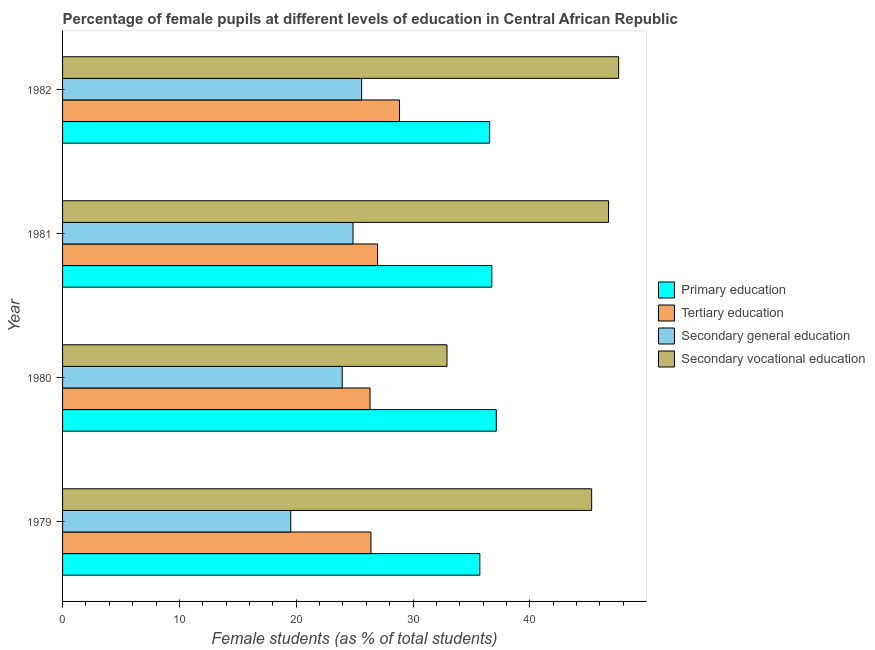How many different coloured bars are there?
Offer a very short reply. 4. Are the number of bars per tick equal to the number of legend labels?
Ensure brevity in your answer.  Yes. Are the number of bars on each tick of the Y-axis equal?
Ensure brevity in your answer.  Yes. How many bars are there on the 1st tick from the bottom?
Give a very brief answer. 4. What is the label of the 3rd group of bars from the top?
Provide a short and direct response. 1980. What is the percentage of female students in tertiary education in 1979?
Make the answer very short. 26.4. Across all years, what is the maximum percentage of female students in secondary education?
Make the answer very short. 25.6. Across all years, what is the minimum percentage of female students in primary education?
Ensure brevity in your answer.  35.72. What is the total percentage of female students in secondary vocational education in the graph?
Offer a terse response. 172.55. What is the difference between the percentage of female students in tertiary education in 1979 and that in 1981?
Provide a short and direct response. -0.57. What is the difference between the percentage of female students in tertiary education in 1980 and the percentage of female students in primary education in 1979?
Your answer should be compact. -9.4. What is the average percentage of female students in primary education per year?
Offer a terse response. 36.54. In the year 1980, what is the difference between the percentage of female students in primary education and percentage of female students in tertiary education?
Your answer should be very brief. 10.8. In how many years, is the percentage of female students in tertiary education greater than 6 %?
Keep it short and to the point. 4. What is the ratio of the percentage of female students in primary education in 1980 to that in 1981?
Your answer should be compact. 1.01. Is the percentage of female students in secondary vocational education in 1980 less than that in 1981?
Give a very brief answer. Yes. Is the difference between the percentage of female students in tertiary education in 1979 and 1982 greater than the difference between the percentage of female students in secondary vocational education in 1979 and 1982?
Offer a terse response. No. What is the difference between the highest and the second highest percentage of female students in secondary education?
Ensure brevity in your answer.  0.74. What is the difference between the highest and the lowest percentage of female students in secondary vocational education?
Your answer should be compact. 14.69. Is the sum of the percentage of female students in secondary vocational education in 1979 and 1982 greater than the maximum percentage of female students in primary education across all years?
Provide a succinct answer. Yes. What does the 4th bar from the top in 1981 represents?
Your response must be concise. Primary education. What does the 3rd bar from the bottom in 1980 represents?
Offer a terse response. Secondary general education. Is it the case that in every year, the sum of the percentage of female students in primary education and percentage of female students in tertiary education is greater than the percentage of female students in secondary education?
Make the answer very short. Yes. Are all the bars in the graph horizontal?
Provide a short and direct response. Yes. How many years are there in the graph?
Your response must be concise. 4. What is the difference between two consecutive major ticks on the X-axis?
Your answer should be very brief. 10. Where does the legend appear in the graph?
Ensure brevity in your answer.  Center right. What is the title of the graph?
Your response must be concise. Percentage of female pupils at different levels of education in Central African Republic. Does "Business regulatory environment" appear as one of the legend labels in the graph?
Ensure brevity in your answer.  No. What is the label or title of the X-axis?
Your response must be concise. Female students (as % of total students). What is the Female students (as % of total students) of Primary education in 1979?
Keep it short and to the point. 35.72. What is the Female students (as % of total students) in Tertiary education in 1979?
Your answer should be compact. 26.4. What is the Female students (as % of total students) of Secondary general education in 1979?
Provide a short and direct response. 19.54. What is the Female students (as % of total students) of Secondary vocational education in 1979?
Make the answer very short. 45.29. What is the Female students (as % of total students) of Primary education in 1980?
Your answer should be very brief. 37.13. What is the Female students (as % of total students) of Tertiary education in 1980?
Keep it short and to the point. 26.32. What is the Female students (as % of total students) in Secondary general education in 1980?
Your response must be concise. 23.94. What is the Female students (as % of total students) of Secondary vocational education in 1980?
Provide a succinct answer. 32.91. What is the Female students (as % of total students) in Primary education in 1981?
Your answer should be very brief. 36.75. What is the Female students (as % of total students) in Tertiary education in 1981?
Offer a very short reply. 26.97. What is the Female students (as % of total students) in Secondary general education in 1981?
Offer a very short reply. 24.86. What is the Female students (as % of total students) in Secondary vocational education in 1981?
Give a very brief answer. 46.74. What is the Female students (as % of total students) of Primary education in 1982?
Provide a succinct answer. 36.56. What is the Female students (as % of total students) in Tertiary education in 1982?
Your answer should be very brief. 28.84. What is the Female students (as % of total students) of Secondary general education in 1982?
Offer a terse response. 25.6. What is the Female students (as % of total students) in Secondary vocational education in 1982?
Ensure brevity in your answer.  47.6. Across all years, what is the maximum Female students (as % of total students) in Primary education?
Your response must be concise. 37.13. Across all years, what is the maximum Female students (as % of total students) in Tertiary education?
Make the answer very short. 28.84. Across all years, what is the maximum Female students (as % of total students) of Secondary general education?
Your response must be concise. 25.6. Across all years, what is the maximum Female students (as % of total students) of Secondary vocational education?
Ensure brevity in your answer.  47.6. Across all years, what is the minimum Female students (as % of total students) of Primary education?
Make the answer very short. 35.72. Across all years, what is the minimum Female students (as % of total students) in Tertiary education?
Provide a succinct answer. 26.32. Across all years, what is the minimum Female students (as % of total students) of Secondary general education?
Your answer should be compact. 19.54. Across all years, what is the minimum Female students (as % of total students) in Secondary vocational education?
Your answer should be very brief. 32.91. What is the total Female students (as % of total students) of Primary education in the graph?
Your response must be concise. 146.16. What is the total Female students (as % of total students) of Tertiary education in the graph?
Your answer should be very brief. 108.53. What is the total Female students (as % of total students) of Secondary general education in the graph?
Keep it short and to the point. 93.94. What is the total Female students (as % of total students) of Secondary vocational education in the graph?
Provide a short and direct response. 172.55. What is the difference between the Female students (as % of total students) in Primary education in 1979 and that in 1980?
Provide a short and direct response. -1.41. What is the difference between the Female students (as % of total students) of Tertiary education in 1979 and that in 1980?
Offer a very short reply. 0.08. What is the difference between the Female students (as % of total students) of Secondary general education in 1979 and that in 1980?
Keep it short and to the point. -4.41. What is the difference between the Female students (as % of total students) in Secondary vocational education in 1979 and that in 1980?
Your answer should be compact. 12.38. What is the difference between the Female students (as % of total students) of Primary education in 1979 and that in 1981?
Ensure brevity in your answer.  -1.03. What is the difference between the Female students (as % of total students) in Tertiary education in 1979 and that in 1981?
Your response must be concise. -0.57. What is the difference between the Female students (as % of total students) in Secondary general education in 1979 and that in 1981?
Your answer should be very brief. -5.33. What is the difference between the Female students (as % of total students) of Secondary vocational education in 1979 and that in 1981?
Provide a succinct answer. -1.45. What is the difference between the Female students (as % of total students) of Primary education in 1979 and that in 1982?
Keep it short and to the point. -0.84. What is the difference between the Female students (as % of total students) of Tertiary education in 1979 and that in 1982?
Offer a terse response. -2.44. What is the difference between the Female students (as % of total students) in Secondary general education in 1979 and that in 1982?
Provide a succinct answer. -6.07. What is the difference between the Female students (as % of total students) in Secondary vocational education in 1979 and that in 1982?
Ensure brevity in your answer.  -2.31. What is the difference between the Female students (as % of total students) in Primary education in 1980 and that in 1981?
Ensure brevity in your answer.  0.38. What is the difference between the Female students (as % of total students) of Tertiary education in 1980 and that in 1981?
Make the answer very short. -0.64. What is the difference between the Female students (as % of total students) of Secondary general education in 1980 and that in 1981?
Make the answer very short. -0.92. What is the difference between the Female students (as % of total students) of Secondary vocational education in 1980 and that in 1981?
Your answer should be very brief. -13.83. What is the difference between the Female students (as % of total students) in Primary education in 1980 and that in 1982?
Make the answer very short. 0.57. What is the difference between the Female students (as % of total students) in Tertiary education in 1980 and that in 1982?
Ensure brevity in your answer.  -2.52. What is the difference between the Female students (as % of total students) of Secondary general education in 1980 and that in 1982?
Offer a very short reply. -1.66. What is the difference between the Female students (as % of total students) in Secondary vocational education in 1980 and that in 1982?
Your answer should be very brief. -14.69. What is the difference between the Female students (as % of total students) of Primary education in 1981 and that in 1982?
Provide a short and direct response. 0.19. What is the difference between the Female students (as % of total students) in Tertiary education in 1981 and that in 1982?
Offer a terse response. -1.87. What is the difference between the Female students (as % of total students) of Secondary general education in 1981 and that in 1982?
Your response must be concise. -0.74. What is the difference between the Female students (as % of total students) in Secondary vocational education in 1981 and that in 1982?
Your answer should be compact. -0.86. What is the difference between the Female students (as % of total students) of Primary education in 1979 and the Female students (as % of total students) of Tertiary education in 1980?
Ensure brevity in your answer.  9.4. What is the difference between the Female students (as % of total students) of Primary education in 1979 and the Female students (as % of total students) of Secondary general education in 1980?
Ensure brevity in your answer.  11.78. What is the difference between the Female students (as % of total students) in Primary education in 1979 and the Female students (as % of total students) in Secondary vocational education in 1980?
Your answer should be very brief. 2.81. What is the difference between the Female students (as % of total students) of Tertiary education in 1979 and the Female students (as % of total students) of Secondary general education in 1980?
Your answer should be very brief. 2.46. What is the difference between the Female students (as % of total students) of Tertiary education in 1979 and the Female students (as % of total students) of Secondary vocational education in 1980?
Give a very brief answer. -6.51. What is the difference between the Female students (as % of total students) in Secondary general education in 1979 and the Female students (as % of total students) in Secondary vocational education in 1980?
Your answer should be compact. -13.38. What is the difference between the Female students (as % of total students) in Primary education in 1979 and the Female students (as % of total students) in Tertiary education in 1981?
Ensure brevity in your answer.  8.75. What is the difference between the Female students (as % of total students) of Primary education in 1979 and the Female students (as % of total students) of Secondary general education in 1981?
Ensure brevity in your answer.  10.86. What is the difference between the Female students (as % of total students) of Primary education in 1979 and the Female students (as % of total students) of Secondary vocational education in 1981?
Offer a very short reply. -11.02. What is the difference between the Female students (as % of total students) in Tertiary education in 1979 and the Female students (as % of total students) in Secondary general education in 1981?
Give a very brief answer. 1.54. What is the difference between the Female students (as % of total students) of Tertiary education in 1979 and the Female students (as % of total students) of Secondary vocational education in 1981?
Your answer should be compact. -20.34. What is the difference between the Female students (as % of total students) in Secondary general education in 1979 and the Female students (as % of total students) in Secondary vocational education in 1981?
Give a very brief answer. -27.21. What is the difference between the Female students (as % of total students) in Primary education in 1979 and the Female students (as % of total students) in Tertiary education in 1982?
Ensure brevity in your answer.  6.88. What is the difference between the Female students (as % of total students) in Primary education in 1979 and the Female students (as % of total students) in Secondary general education in 1982?
Offer a terse response. 10.12. What is the difference between the Female students (as % of total students) of Primary education in 1979 and the Female students (as % of total students) of Secondary vocational education in 1982?
Your answer should be compact. -11.88. What is the difference between the Female students (as % of total students) of Tertiary education in 1979 and the Female students (as % of total students) of Secondary general education in 1982?
Your answer should be very brief. 0.8. What is the difference between the Female students (as % of total students) of Tertiary education in 1979 and the Female students (as % of total students) of Secondary vocational education in 1982?
Your answer should be very brief. -21.2. What is the difference between the Female students (as % of total students) in Secondary general education in 1979 and the Female students (as % of total students) in Secondary vocational education in 1982?
Your response must be concise. -28.07. What is the difference between the Female students (as % of total students) in Primary education in 1980 and the Female students (as % of total students) in Tertiary education in 1981?
Provide a succinct answer. 10.16. What is the difference between the Female students (as % of total students) in Primary education in 1980 and the Female students (as % of total students) in Secondary general education in 1981?
Provide a succinct answer. 12.26. What is the difference between the Female students (as % of total students) in Primary education in 1980 and the Female students (as % of total students) in Secondary vocational education in 1981?
Your answer should be compact. -9.61. What is the difference between the Female students (as % of total students) in Tertiary education in 1980 and the Female students (as % of total students) in Secondary general education in 1981?
Ensure brevity in your answer.  1.46. What is the difference between the Female students (as % of total students) in Tertiary education in 1980 and the Female students (as % of total students) in Secondary vocational education in 1981?
Offer a very short reply. -20.42. What is the difference between the Female students (as % of total students) of Secondary general education in 1980 and the Female students (as % of total students) of Secondary vocational education in 1981?
Keep it short and to the point. -22.8. What is the difference between the Female students (as % of total students) in Primary education in 1980 and the Female students (as % of total students) in Tertiary education in 1982?
Offer a terse response. 8.29. What is the difference between the Female students (as % of total students) of Primary education in 1980 and the Female students (as % of total students) of Secondary general education in 1982?
Your answer should be compact. 11.53. What is the difference between the Female students (as % of total students) in Primary education in 1980 and the Female students (as % of total students) in Secondary vocational education in 1982?
Give a very brief answer. -10.48. What is the difference between the Female students (as % of total students) in Tertiary education in 1980 and the Female students (as % of total students) in Secondary general education in 1982?
Ensure brevity in your answer.  0.72. What is the difference between the Female students (as % of total students) in Tertiary education in 1980 and the Female students (as % of total students) in Secondary vocational education in 1982?
Offer a very short reply. -21.28. What is the difference between the Female students (as % of total students) in Secondary general education in 1980 and the Female students (as % of total students) in Secondary vocational education in 1982?
Provide a short and direct response. -23.66. What is the difference between the Female students (as % of total students) of Primary education in 1981 and the Female students (as % of total students) of Tertiary education in 1982?
Provide a short and direct response. 7.91. What is the difference between the Female students (as % of total students) in Primary education in 1981 and the Female students (as % of total students) in Secondary general education in 1982?
Give a very brief answer. 11.15. What is the difference between the Female students (as % of total students) of Primary education in 1981 and the Female students (as % of total students) of Secondary vocational education in 1982?
Make the answer very short. -10.86. What is the difference between the Female students (as % of total students) of Tertiary education in 1981 and the Female students (as % of total students) of Secondary general education in 1982?
Offer a terse response. 1.37. What is the difference between the Female students (as % of total students) in Tertiary education in 1981 and the Female students (as % of total students) in Secondary vocational education in 1982?
Give a very brief answer. -20.64. What is the difference between the Female students (as % of total students) of Secondary general education in 1981 and the Female students (as % of total students) of Secondary vocational education in 1982?
Provide a succinct answer. -22.74. What is the average Female students (as % of total students) of Primary education per year?
Provide a succinct answer. 36.54. What is the average Female students (as % of total students) of Tertiary education per year?
Offer a terse response. 27.13. What is the average Female students (as % of total students) in Secondary general education per year?
Make the answer very short. 23.49. What is the average Female students (as % of total students) in Secondary vocational education per year?
Provide a short and direct response. 43.14. In the year 1979, what is the difference between the Female students (as % of total students) in Primary education and Female students (as % of total students) in Tertiary education?
Your response must be concise. 9.32. In the year 1979, what is the difference between the Female students (as % of total students) of Primary education and Female students (as % of total students) of Secondary general education?
Your answer should be compact. 16.19. In the year 1979, what is the difference between the Female students (as % of total students) of Primary education and Female students (as % of total students) of Secondary vocational education?
Your answer should be compact. -9.57. In the year 1979, what is the difference between the Female students (as % of total students) of Tertiary education and Female students (as % of total students) of Secondary general education?
Give a very brief answer. 6.87. In the year 1979, what is the difference between the Female students (as % of total students) in Tertiary education and Female students (as % of total students) in Secondary vocational education?
Your answer should be very brief. -18.89. In the year 1979, what is the difference between the Female students (as % of total students) in Secondary general education and Female students (as % of total students) in Secondary vocational education?
Your answer should be very brief. -25.76. In the year 1980, what is the difference between the Female students (as % of total students) of Primary education and Female students (as % of total students) of Tertiary education?
Keep it short and to the point. 10.81. In the year 1980, what is the difference between the Female students (as % of total students) in Primary education and Female students (as % of total students) in Secondary general education?
Your response must be concise. 13.19. In the year 1980, what is the difference between the Female students (as % of total students) in Primary education and Female students (as % of total students) in Secondary vocational education?
Your response must be concise. 4.22. In the year 1980, what is the difference between the Female students (as % of total students) of Tertiary education and Female students (as % of total students) of Secondary general education?
Offer a terse response. 2.38. In the year 1980, what is the difference between the Female students (as % of total students) in Tertiary education and Female students (as % of total students) in Secondary vocational education?
Offer a very short reply. -6.59. In the year 1980, what is the difference between the Female students (as % of total students) in Secondary general education and Female students (as % of total students) in Secondary vocational education?
Your response must be concise. -8.97. In the year 1981, what is the difference between the Female students (as % of total students) in Primary education and Female students (as % of total students) in Tertiary education?
Provide a succinct answer. 9.78. In the year 1981, what is the difference between the Female students (as % of total students) in Primary education and Female students (as % of total students) in Secondary general education?
Your answer should be very brief. 11.89. In the year 1981, what is the difference between the Female students (as % of total students) of Primary education and Female students (as % of total students) of Secondary vocational education?
Keep it short and to the point. -9.99. In the year 1981, what is the difference between the Female students (as % of total students) in Tertiary education and Female students (as % of total students) in Secondary general education?
Offer a terse response. 2.1. In the year 1981, what is the difference between the Female students (as % of total students) of Tertiary education and Female students (as % of total students) of Secondary vocational education?
Ensure brevity in your answer.  -19.77. In the year 1981, what is the difference between the Female students (as % of total students) of Secondary general education and Female students (as % of total students) of Secondary vocational education?
Your response must be concise. -21.88. In the year 1982, what is the difference between the Female students (as % of total students) in Primary education and Female students (as % of total students) in Tertiary education?
Provide a short and direct response. 7.72. In the year 1982, what is the difference between the Female students (as % of total students) of Primary education and Female students (as % of total students) of Secondary general education?
Your response must be concise. 10.96. In the year 1982, what is the difference between the Female students (as % of total students) of Primary education and Female students (as % of total students) of Secondary vocational education?
Your answer should be very brief. -11.04. In the year 1982, what is the difference between the Female students (as % of total students) in Tertiary education and Female students (as % of total students) in Secondary general education?
Your response must be concise. 3.24. In the year 1982, what is the difference between the Female students (as % of total students) in Tertiary education and Female students (as % of total students) in Secondary vocational education?
Your answer should be compact. -18.76. In the year 1982, what is the difference between the Female students (as % of total students) in Secondary general education and Female students (as % of total students) in Secondary vocational education?
Provide a short and direct response. -22. What is the ratio of the Female students (as % of total students) in Primary education in 1979 to that in 1980?
Keep it short and to the point. 0.96. What is the ratio of the Female students (as % of total students) of Secondary general education in 1979 to that in 1980?
Make the answer very short. 0.82. What is the ratio of the Female students (as % of total students) of Secondary vocational education in 1979 to that in 1980?
Make the answer very short. 1.38. What is the ratio of the Female students (as % of total students) in Primary education in 1979 to that in 1981?
Your response must be concise. 0.97. What is the ratio of the Female students (as % of total students) of Tertiary education in 1979 to that in 1981?
Your response must be concise. 0.98. What is the ratio of the Female students (as % of total students) of Secondary general education in 1979 to that in 1981?
Offer a very short reply. 0.79. What is the ratio of the Female students (as % of total students) in Secondary vocational education in 1979 to that in 1981?
Your answer should be very brief. 0.97. What is the ratio of the Female students (as % of total students) in Tertiary education in 1979 to that in 1982?
Offer a terse response. 0.92. What is the ratio of the Female students (as % of total students) in Secondary general education in 1979 to that in 1982?
Your answer should be very brief. 0.76. What is the ratio of the Female students (as % of total students) of Secondary vocational education in 1979 to that in 1982?
Keep it short and to the point. 0.95. What is the ratio of the Female students (as % of total students) in Primary education in 1980 to that in 1981?
Ensure brevity in your answer.  1.01. What is the ratio of the Female students (as % of total students) of Tertiary education in 1980 to that in 1981?
Offer a very short reply. 0.98. What is the ratio of the Female students (as % of total students) in Secondary vocational education in 1980 to that in 1981?
Give a very brief answer. 0.7. What is the ratio of the Female students (as % of total students) in Primary education in 1980 to that in 1982?
Keep it short and to the point. 1.02. What is the ratio of the Female students (as % of total students) in Tertiary education in 1980 to that in 1982?
Your response must be concise. 0.91. What is the ratio of the Female students (as % of total students) in Secondary general education in 1980 to that in 1982?
Your answer should be compact. 0.94. What is the ratio of the Female students (as % of total students) of Secondary vocational education in 1980 to that in 1982?
Your response must be concise. 0.69. What is the ratio of the Female students (as % of total students) in Primary education in 1981 to that in 1982?
Provide a short and direct response. 1.01. What is the ratio of the Female students (as % of total students) of Tertiary education in 1981 to that in 1982?
Make the answer very short. 0.94. What is the ratio of the Female students (as % of total students) of Secondary general education in 1981 to that in 1982?
Make the answer very short. 0.97. What is the ratio of the Female students (as % of total students) in Secondary vocational education in 1981 to that in 1982?
Provide a succinct answer. 0.98. What is the difference between the highest and the second highest Female students (as % of total students) of Primary education?
Give a very brief answer. 0.38. What is the difference between the highest and the second highest Female students (as % of total students) in Tertiary education?
Your response must be concise. 1.87. What is the difference between the highest and the second highest Female students (as % of total students) of Secondary general education?
Your answer should be compact. 0.74. What is the difference between the highest and the second highest Female students (as % of total students) of Secondary vocational education?
Keep it short and to the point. 0.86. What is the difference between the highest and the lowest Female students (as % of total students) in Primary education?
Give a very brief answer. 1.41. What is the difference between the highest and the lowest Female students (as % of total students) of Tertiary education?
Provide a succinct answer. 2.52. What is the difference between the highest and the lowest Female students (as % of total students) of Secondary general education?
Give a very brief answer. 6.07. What is the difference between the highest and the lowest Female students (as % of total students) in Secondary vocational education?
Provide a short and direct response. 14.69. 